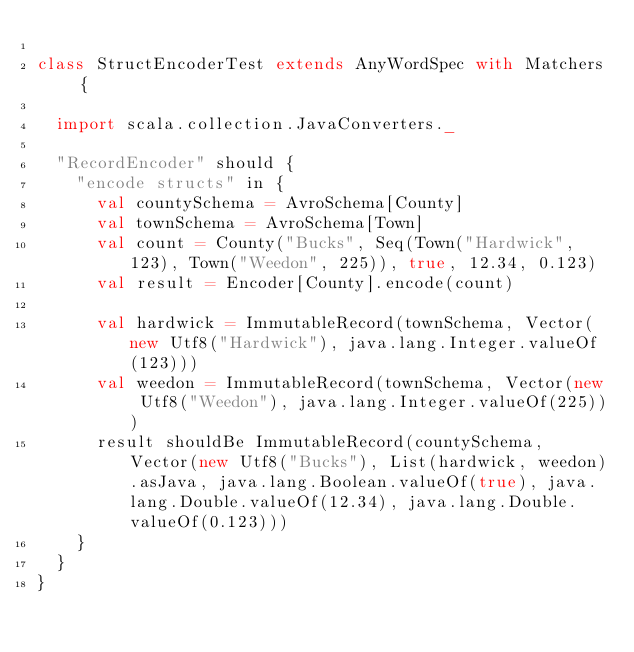Convert code to text. <code><loc_0><loc_0><loc_500><loc_500><_Scala_>
class StructEncoderTest extends AnyWordSpec with Matchers {

  import scala.collection.JavaConverters._

  "RecordEncoder" should {
    "encode structs" in {
      val countySchema = AvroSchema[County]
      val townSchema = AvroSchema[Town]
      val count = County("Bucks", Seq(Town("Hardwick", 123), Town("Weedon", 225)), true, 12.34, 0.123)
      val result = Encoder[County].encode(count)

      val hardwick = ImmutableRecord(townSchema, Vector(new Utf8("Hardwick"), java.lang.Integer.valueOf(123)))
      val weedon = ImmutableRecord(townSchema, Vector(new Utf8("Weedon"), java.lang.Integer.valueOf(225)))
      result shouldBe ImmutableRecord(countySchema, Vector(new Utf8("Bucks"), List(hardwick, weedon).asJava, java.lang.Boolean.valueOf(true), java.lang.Double.valueOf(12.34), java.lang.Double.valueOf(0.123)))
    }
  }
}
</code> 